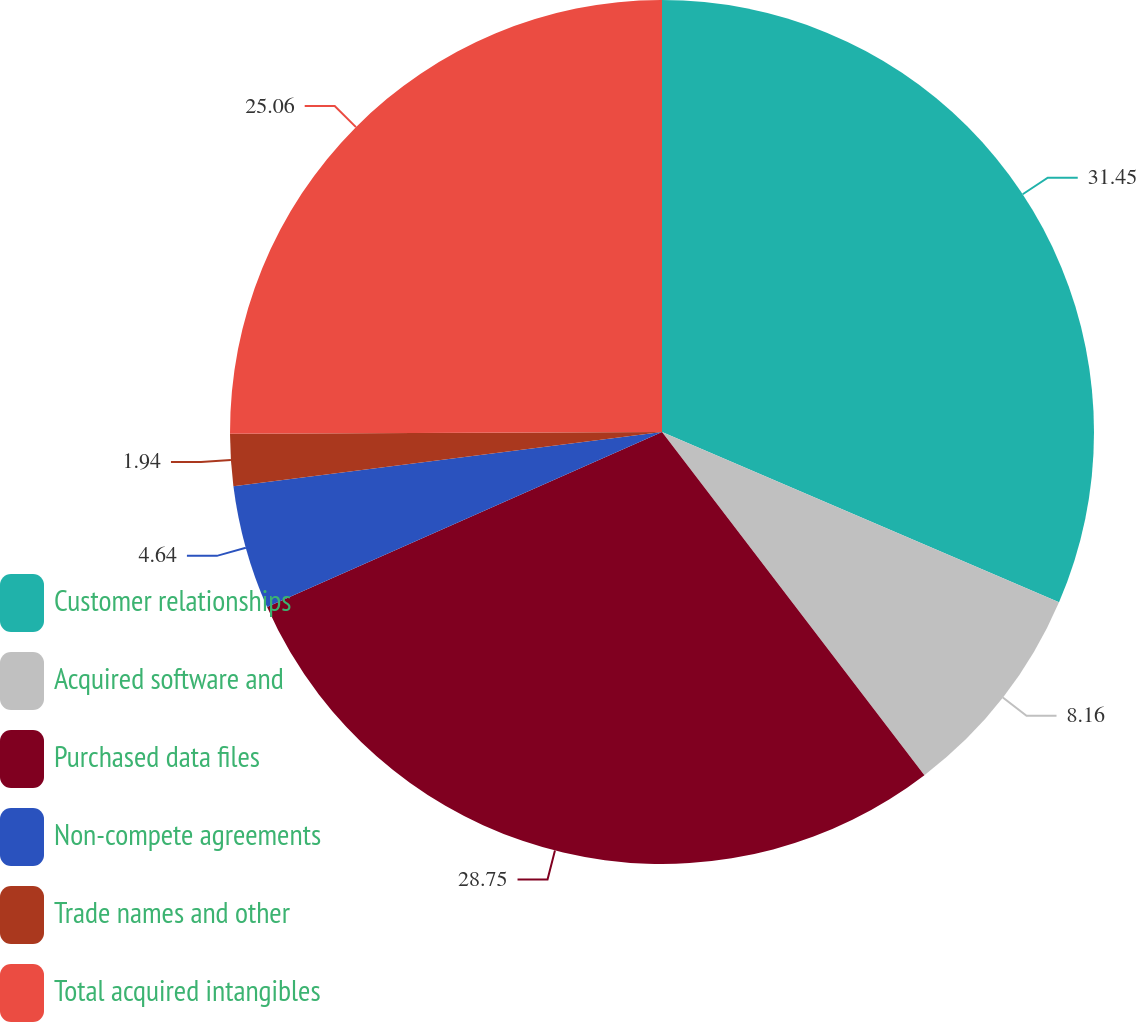Convert chart to OTSL. <chart><loc_0><loc_0><loc_500><loc_500><pie_chart><fcel>Customer relationships<fcel>Acquired software and<fcel>Purchased data files<fcel>Non-compete agreements<fcel>Trade names and other<fcel>Total acquired intangibles<nl><fcel>31.45%<fcel>8.16%<fcel>28.75%<fcel>4.64%<fcel>1.94%<fcel>25.06%<nl></chart> 